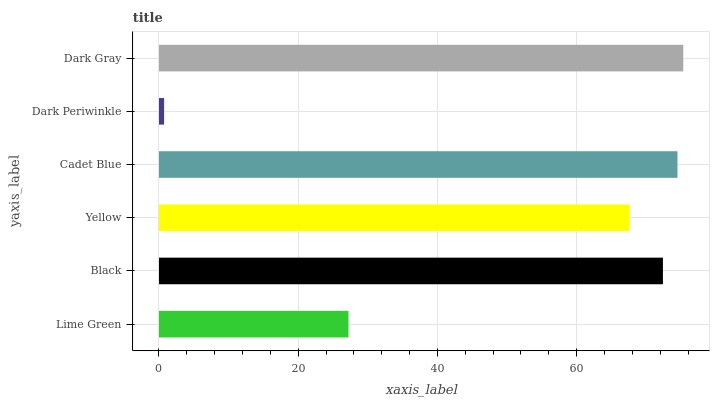Is Dark Periwinkle the minimum?
Answer yes or no. Yes. Is Dark Gray the maximum?
Answer yes or no. Yes. Is Black the minimum?
Answer yes or no. No. Is Black the maximum?
Answer yes or no. No. Is Black greater than Lime Green?
Answer yes or no. Yes. Is Lime Green less than Black?
Answer yes or no. Yes. Is Lime Green greater than Black?
Answer yes or no. No. Is Black less than Lime Green?
Answer yes or no. No. Is Black the high median?
Answer yes or no. Yes. Is Yellow the low median?
Answer yes or no. Yes. Is Dark Periwinkle the high median?
Answer yes or no. No. Is Black the low median?
Answer yes or no. No. 